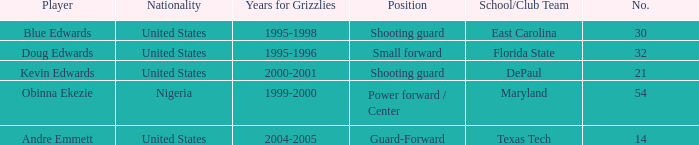When did no. 32 play for grizzles 1995-1996. 